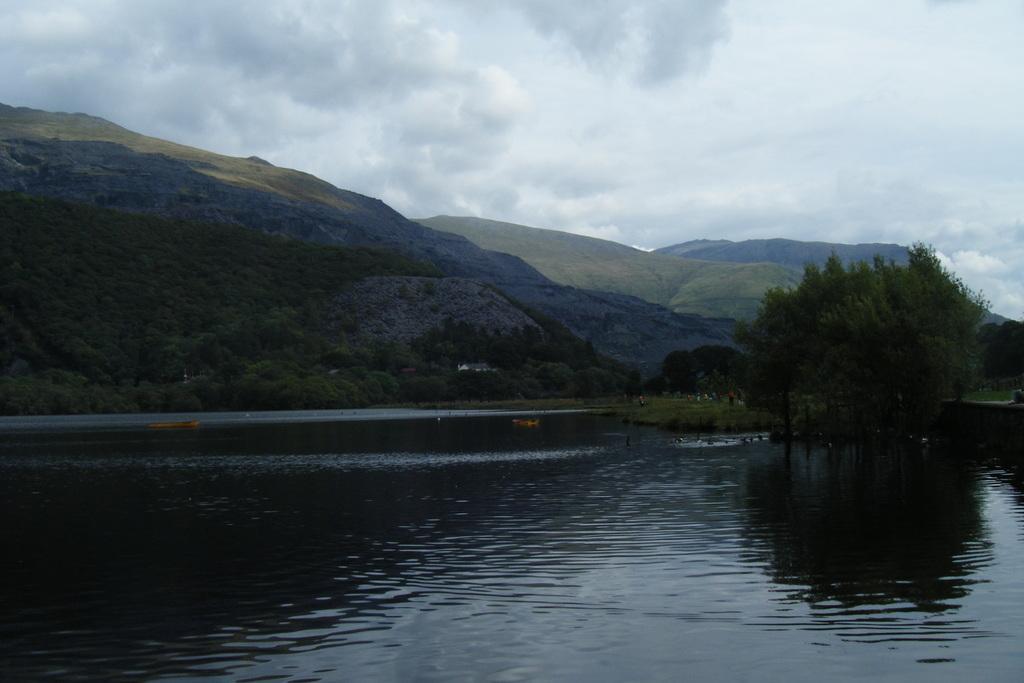Can you describe this image briefly? In this image there is a lake, in the background there are trees, mountains and a cloudy sky. 